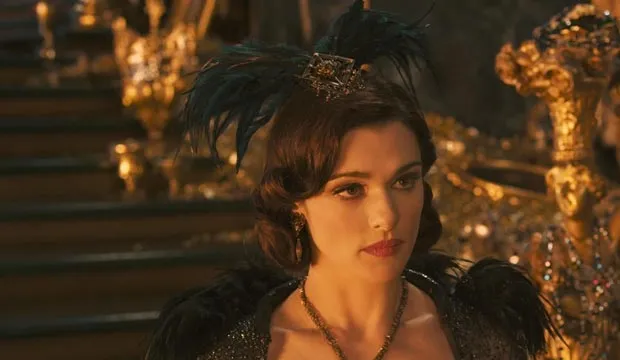Can you describe the main features of this image for me? The image presents Rachel Weisz portraying the character Evanora from 'Oz the Great and Powerful'. She is depicted standing majestically in front of an ornate golden throne, which emphasizes her status within the film. Clad in a lavish black and gold gown complemented by a dramatic feathered headpiece that includes a gold crown, her attire symbolizes both her elegance and underlying malevolence. The serious expression on her face and her distant gaze suggest a contemplation of dark schemes, reflecting her role as a primary antagonist in the movie. This visualization not only captures her regal bearing but also subtly hints at the conflict central to the film's plot. 